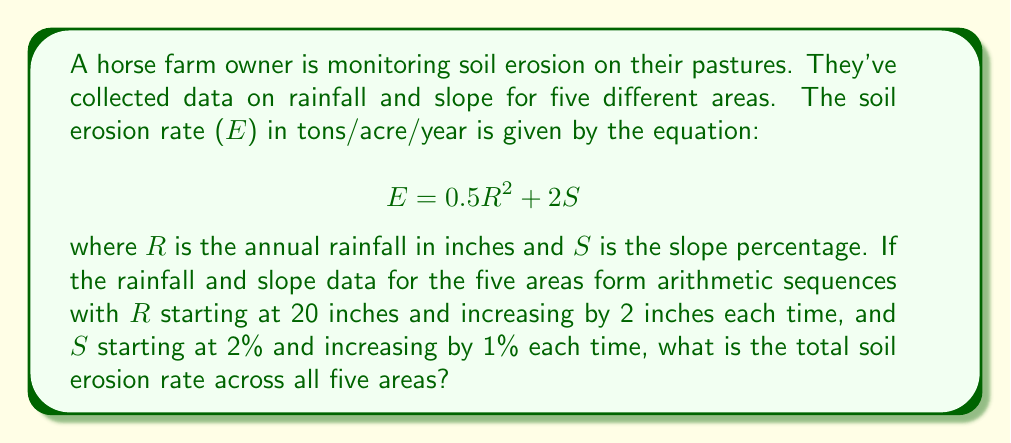Could you help me with this problem? Let's approach this step-by-step:

1) First, let's identify the sequences for R and S:
   R: 20, 22, 24, 26, 28
   S: 2, 3, 4, 5, 6

2) Now, we'll calculate E for each area:

   Area 1: $$E_1 = 0.5(20^2) + 2(2) = 200 + 4 = 204$$
   Area 2: $$E_2 = 0.5(22^2) + 2(3) = 242 + 6 = 248$$
   Area 3: $$E_3 = 0.5(24^2) + 2(4) = 288 + 8 = 296$$
   Area 4: $$E_4 = 0.5(26^2) + 2(5) = 338 + 10 = 348$$
   Area 5: $$E_5 = 0.5(28^2) + 2(6) = 392 + 12 = 404$$

3) To get the total erosion rate, we sum these values:

   $$E_{total} = E_1 + E_2 + E_3 + E_4 + E_5$$
   $$E_{total} = 204 + 248 + 296 + 348 + 404 = 1500$$

Therefore, the total soil erosion rate across all five areas is 1500 tons/acre/year.
Answer: 1500 tons/acre/year 